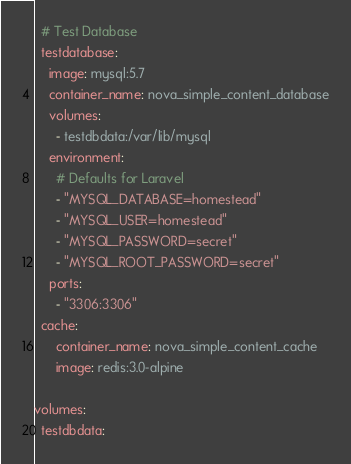Convert code to text. <code><loc_0><loc_0><loc_500><loc_500><_YAML_>
  # Test Database
  testdatabase:
    image: mysql:5.7
    container_name: nova_simple_content_database
    volumes:
      - testdbdata:/var/lib/mysql
    environment:
      # Defaults for Laravel
      - "MYSQL_DATABASE=homestead"
      - "MYSQL_USER=homestead"
      - "MYSQL_PASSWORD=secret"
      - "MYSQL_ROOT_PASSWORD=secret"
    ports:
      - "3306:3306"
  cache:
      container_name: nova_simple_content_cache
      image: redis:3.0-alpine

volumes:
  testdbdata:</code> 